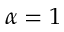<formula> <loc_0><loc_0><loc_500><loc_500>\alpha = 1</formula> 